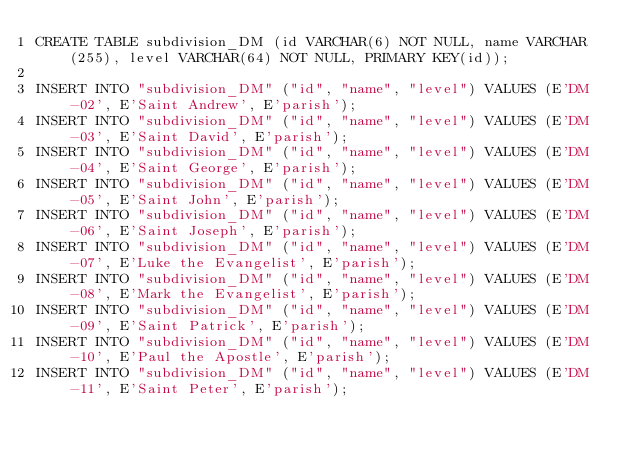<code> <loc_0><loc_0><loc_500><loc_500><_SQL_>CREATE TABLE subdivision_DM (id VARCHAR(6) NOT NULL, name VARCHAR(255), level VARCHAR(64) NOT NULL, PRIMARY KEY(id));

INSERT INTO "subdivision_DM" ("id", "name", "level") VALUES (E'DM-02', E'Saint Andrew', E'parish');
INSERT INTO "subdivision_DM" ("id", "name", "level") VALUES (E'DM-03', E'Saint David', E'parish');
INSERT INTO "subdivision_DM" ("id", "name", "level") VALUES (E'DM-04', E'Saint George', E'parish');
INSERT INTO "subdivision_DM" ("id", "name", "level") VALUES (E'DM-05', E'Saint John', E'parish');
INSERT INTO "subdivision_DM" ("id", "name", "level") VALUES (E'DM-06', E'Saint Joseph', E'parish');
INSERT INTO "subdivision_DM" ("id", "name", "level") VALUES (E'DM-07', E'Luke the Evangelist', E'parish');
INSERT INTO "subdivision_DM" ("id", "name", "level") VALUES (E'DM-08', E'Mark the Evangelist', E'parish');
INSERT INTO "subdivision_DM" ("id", "name", "level") VALUES (E'DM-09', E'Saint Patrick', E'parish');
INSERT INTO "subdivision_DM" ("id", "name", "level") VALUES (E'DM-10', E'Paul the Apostle', E'parish');
INSERT INTO "subdivision_DM" ("id", "name", "level") VALUES (E'DM-11', E'Saint Peter', E'parish');
</code> 